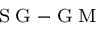<formula> <loc_0><loc_0><loc_500><loc_500>_ { S G - G M }</formula> 